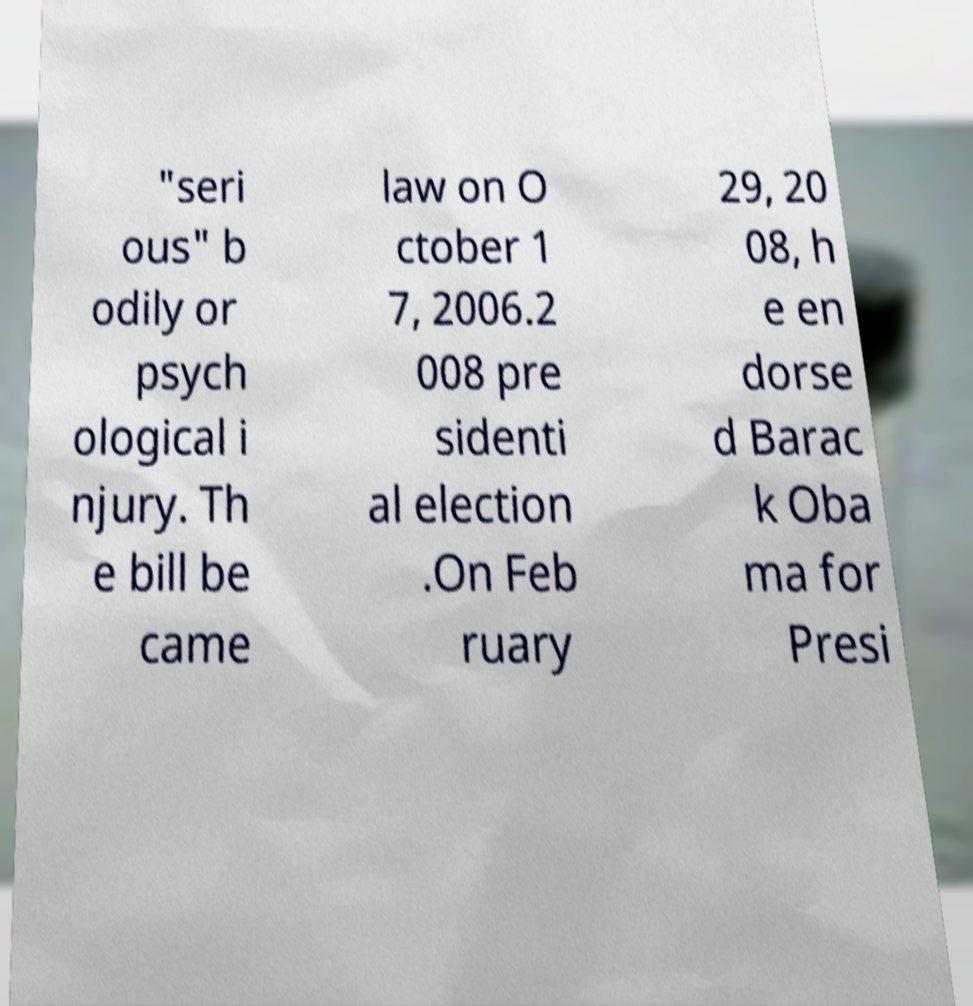Please read and relay the text visible in this image. What does it say? "seri ous" b odily or psych ological i njury. Th e bill be came law on O ctober 1 7, 2006.2 008 pre sidenti al election .On Feb ruary 29, 20 08, h e en dorse d Barac k Oba ma for Presi 